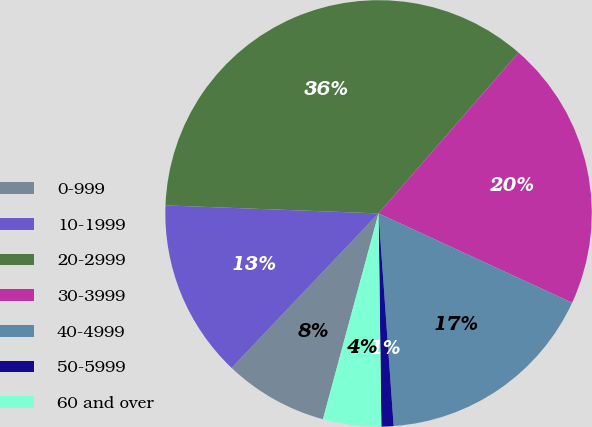Convert chart. <chart><loc_0><loc_0><loc_500><loc_500><pie_chart><fcel>0-999<fcel>10-1999<fcel>20-2999<fcel>30-3999<fcel>40-4999<fcel>50-5999<fcel>60 and over<nl><fcel>7.9%<fcel>13.5%<fcel>35.81%<fcel>20.48%<fcel>16.99%<fcel>0.92%<fcel>4.41%<nl></chart> 